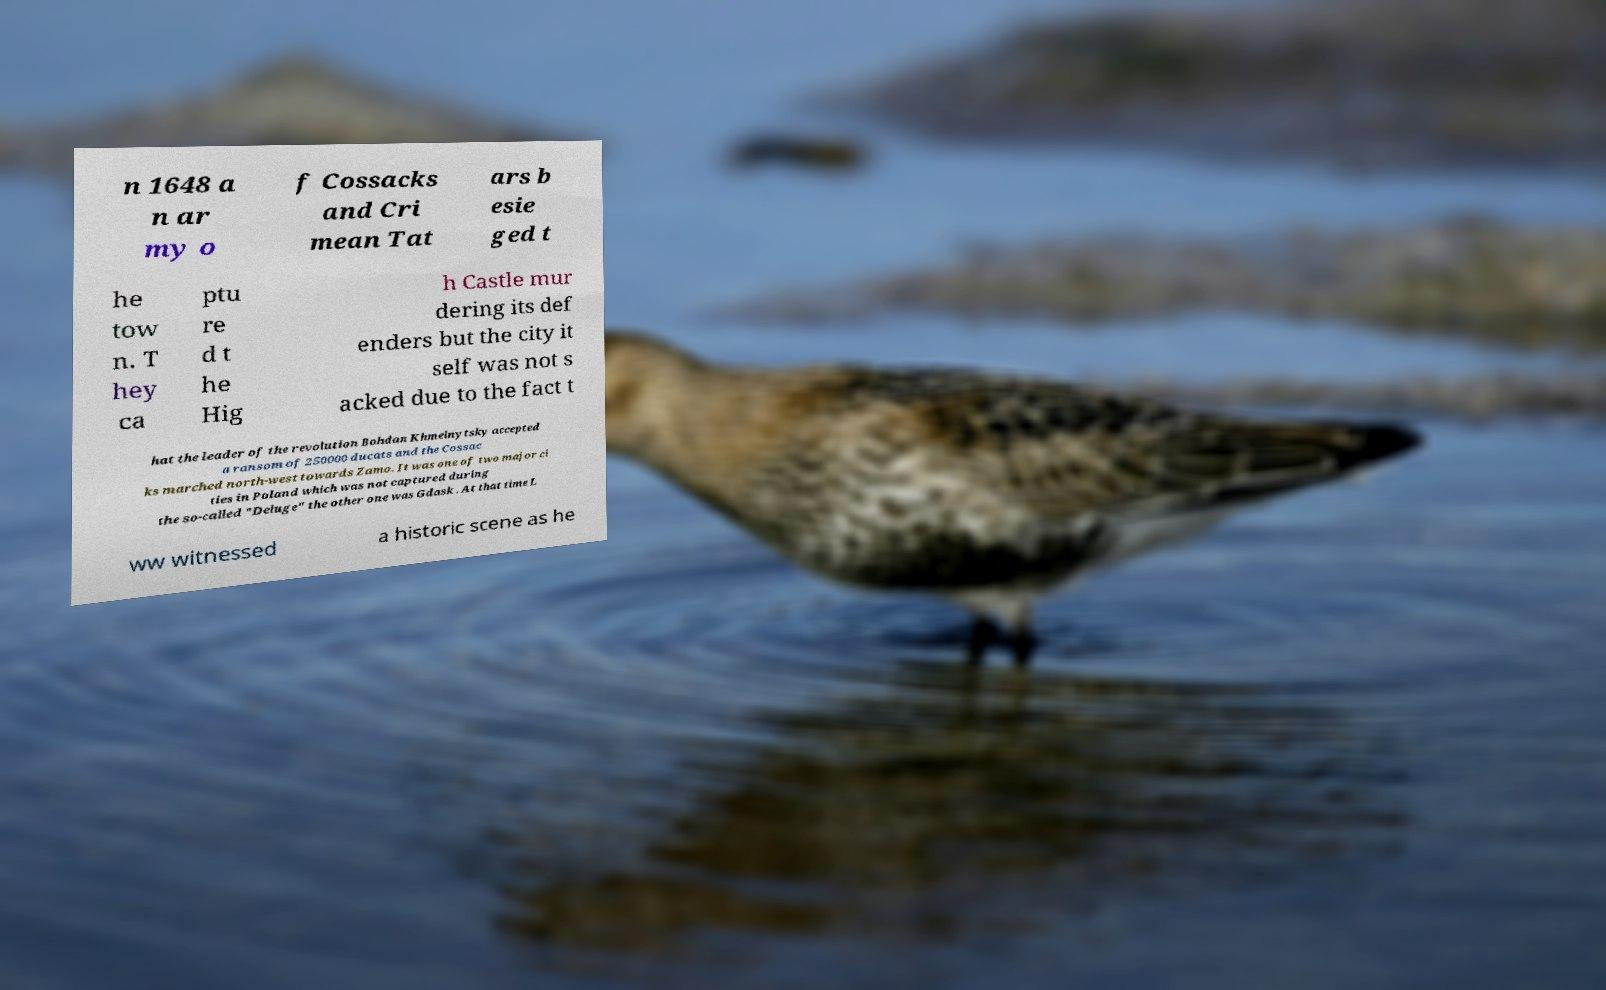Could you assist in decoding the text presented in this image and type it out clearly? n 1648 a n ar my o f Cossacks and Cri mean Tat ars b esie ged t he tow n. T hey ca ptu re d t he Hig h Castle mur dering its def enders but the city it self was not s acked due to the fact t hat the leader of the revolution Bohdan Khmelnytsky accepted a ransom of 250000 ducats and the Cossac ks marched north-west towards Zamo. It was one of two major ci ties in Poland which was not captured during the so-called "Deluge" the other one was Gdask . At that time L ww witnessed a historic scene as he 